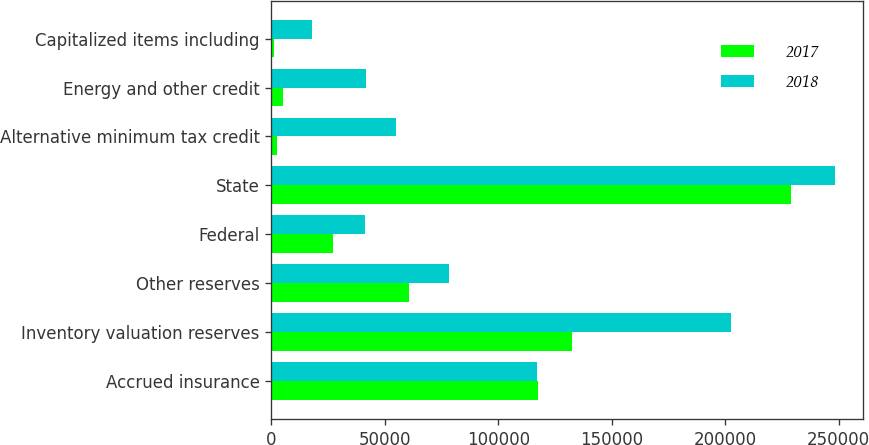Convert chart. <chart><loc_0><loc_0><loc_500><loc_500><stacked_bar_chart><ecel><fcel>Accrued insurance<fcel>Inventory valuation reserves<fcel>Other reserves<fcel>Federal<fcel>State<fcel>Alternative minimum tax credit<fcel>Energy and other credit<fcel>Capitalized items including<nl><fcel>2017<fcel>117682<fcel>132495<fcel>60585<fcel>27122<fcel>228959<fcel>2546<fcel>5146<fcel>1038<nl><fcel>2018<fcel>117133<fcel>202791<fcel>78271<fcel>41282<fcel>248224<fcel>54965<fcel>41763<fcel>17895<nl></chart> 